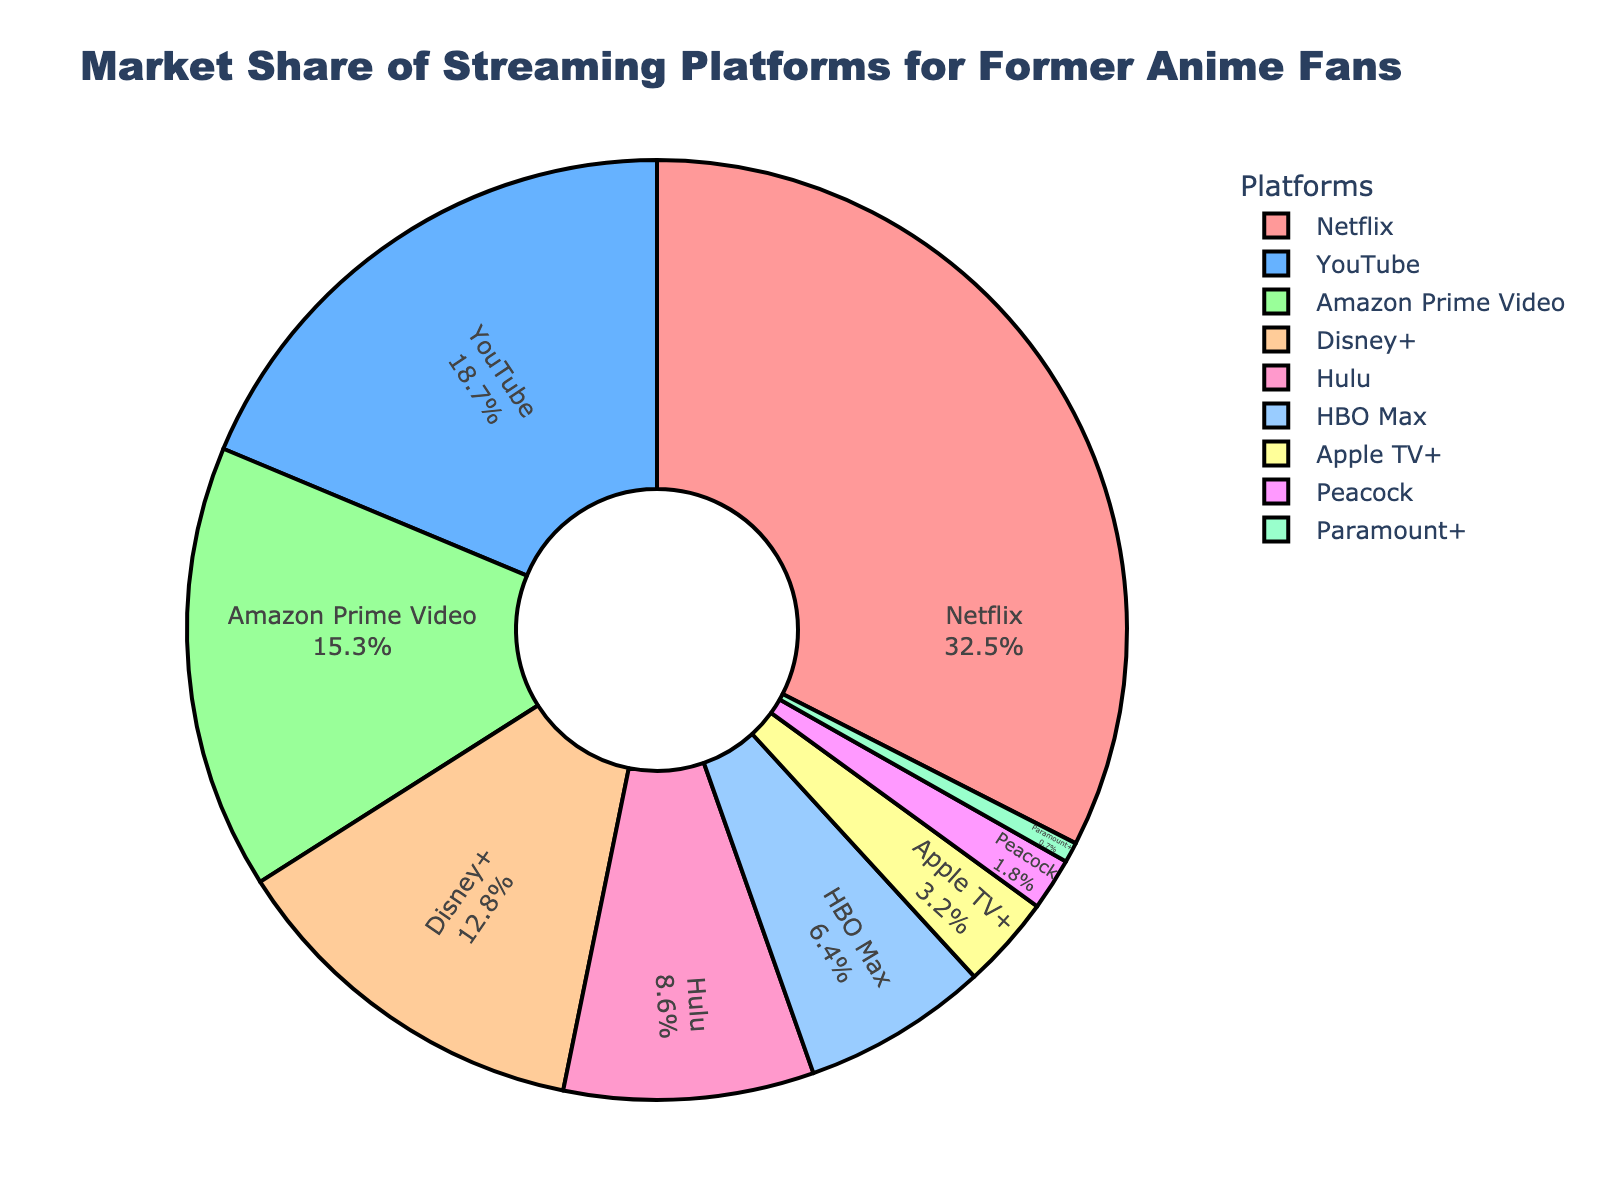What's the platform with the largest market share? The pie chart shows the market share percentages for each streaming platform. The platform with the largest market share can be identified by the largest segment.
Answer: Netflix How much more percentage does Netflix have compared to Amazon Prime Video? To find the difference in market share percentage, subtract Amazon Prime Video's market share from Netflix's market share: 32.5% - 15.3% = 17.2%.
Answer: 17.2% Which platforms combined have a market share of over 50%? Add the percentages of the platforms until the sum exceeds 50%. Netflix (32.5%) + YouTube (18.7%) = 51.2%. These two platforms together exceed 50%.
Answer: Netflix and YouTube What is the combined market share of Disney+ and Hulu? Add the market shares of Disney+ and Hulu: 12.8% + 8.6% = 21.4%.
Answer: 21.4% Between Apple TV+ and Peacock, which has a smaller market share? Compare the market share percentages of Apple TV+ (3.2%) and Peacock (1.8%). Peacock has a smaller market share.
Answer: Peacock What color represents the platform with the smallest market share? Identify the segment with the smallest percentage and observe its color. Paramount+ (0.7%) is the smallest, and it is colored purple (based on the given color scheme).
Answer: Purple How many platforms have a market share greater than 10%? Count the segments with market shares above 10%. Netflix (32.5%), YouTube (18.7%), Amazon Prime Video (15.3%), and Disney+ (12.8%) make up four platforms.
Answer: Four Do Netflix and Hulu together hold a larger market share than YouTube? Find the combined market share of Netflix and Hulu: 32.5% + 8.6% = 41.1%. Compare this with YouTube's 18.7%; 41.1% is larger than 18.7%.
Answer: Yes Which platform's market share is closest to one-third of Netflix's? Calculate one-third of Netflix's market share: 32.5% / 3 ≈ 10.83%. Compare this to other platforms' market shares. Hulu (8.6%) is the closest.
Answer: Hulu Is Amazon Prime Video's market share greater than the combined market share of HBO Max and Apple TV+? Add the market shares of HBO Max and Apple TV+: 6.4% + 3.2% = 9.6%. Compare this to Amazon Prime Video's market share of 15.3%. 15.3% is greater than 9.6%.
Answer: Yes 